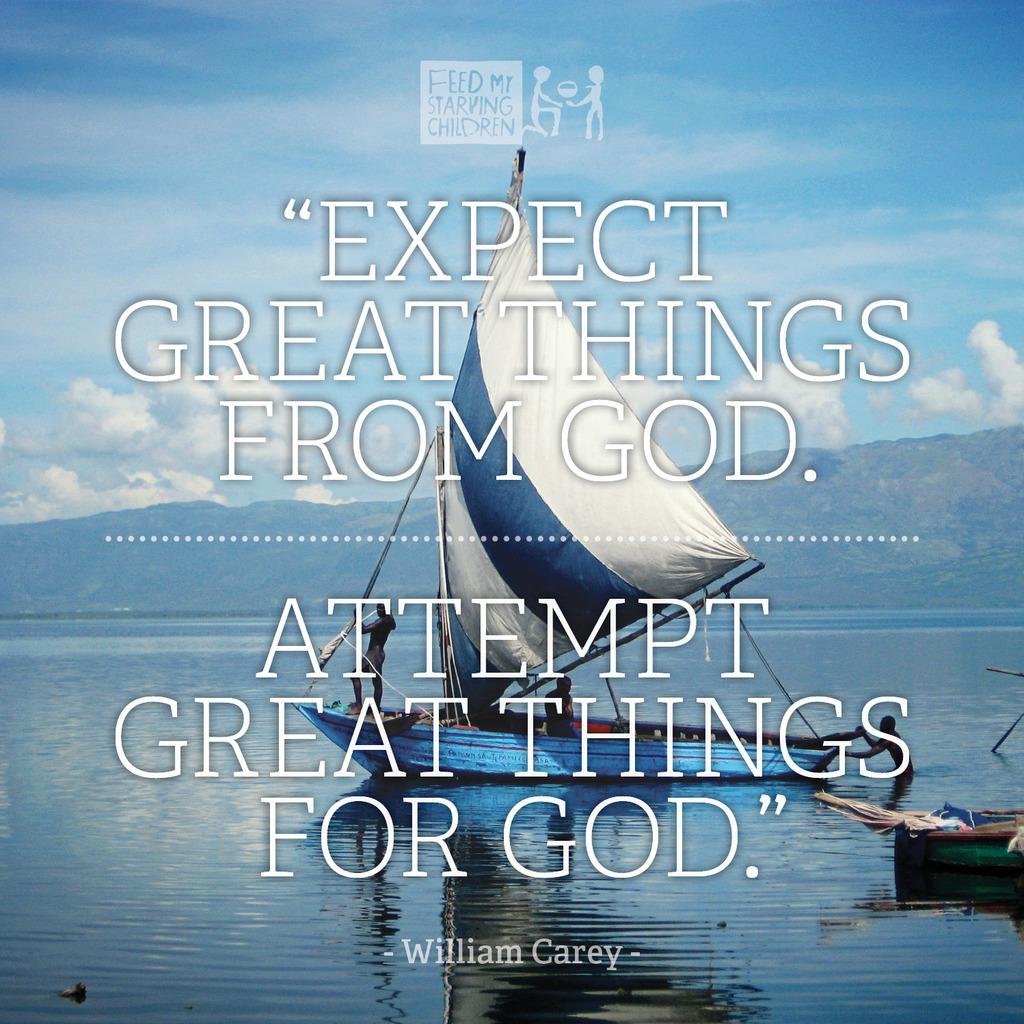Who wrote this?
Provide a succinct answer. William carey. What is the quote at the top of the picture?
Make the answer very short. Expect great things from god. 